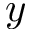<formula> <loc_0><loc_0><loc_500><loc_500>y</formula> 